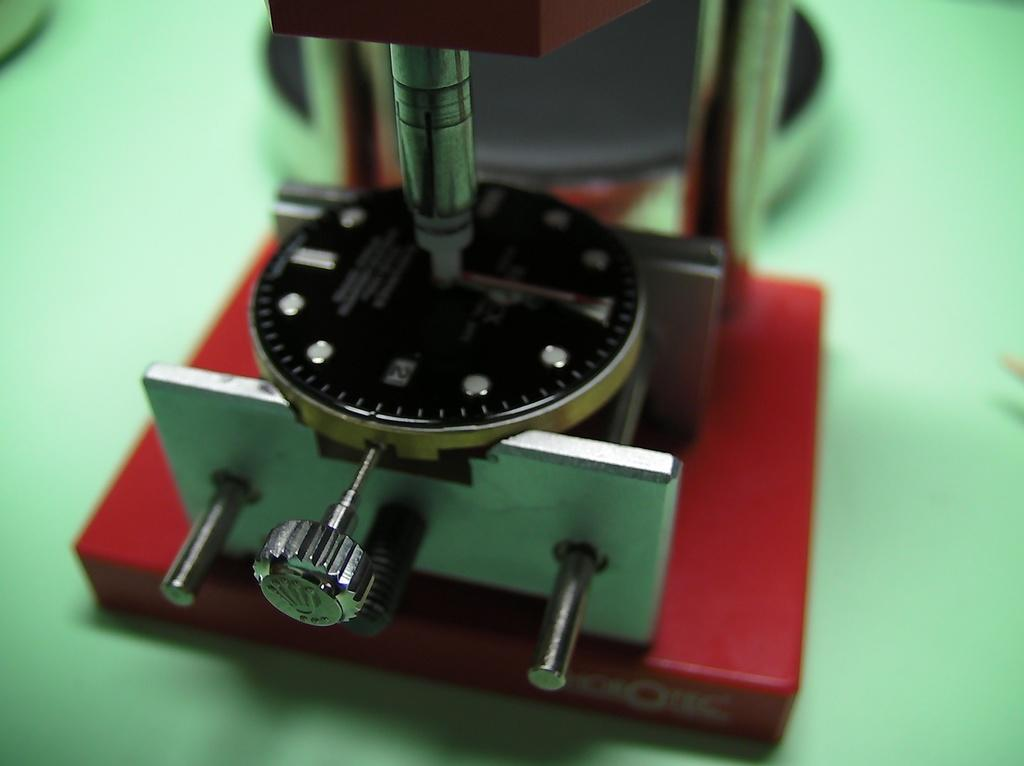What is the main subject of the image? The main subject of the image is a machine. Can you describe the appearance of the machine? The machine is in red and black color. What is the color of the background in the image? The background of the image is green in color. Can you tell me how many books are visible in the library in the image? There is no library or books present in the image; it features a machine in red and black color with a green background. What type of animal is the tramp riding in the image? There is no tramp or animal present in the image; it features a machine in red and black color with a green background. 